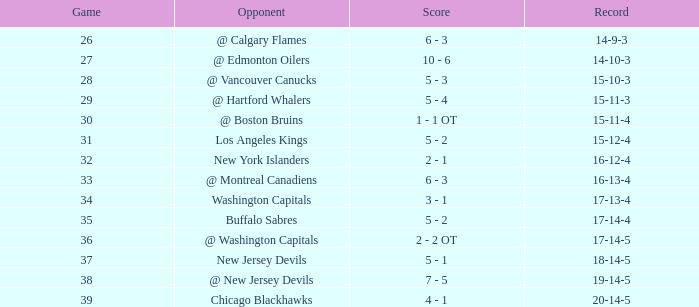Give me the full table as a dictionary. {'header': ['Game', 'Opponent', 'Score', 'Record'], 'rows': [['26', '@ Calgary Flames', '6 - 3', '14-9-3'], ['27', '@ Edmonton Oilers', '10 - 6', '14-10-3'], ['28', '@ Vancouver Canucks', '5 - 3', '15-10-3'], ['29', '@ Hartford Whalers', '5 - 4', '15-11-3'], ['30', '@ Boston Bruins', '1 - 1 OT', '15-11-4'], ['31', 'Los Angeles Kings', '5 - 2', '15-12-4'], ['32', 'New York Islanders', '2 - 1', '16-12-4'], ['33', '@ Montreal Canadiens', '6 - 3', '16-13-4'], ['34', 'Washington Capitals', '3 - 1', '17-13-4'], ['35', 'Buffalo Sabres', '5 - 2', '17-14-4'], ['36', '@ Washington Capitals', '2 - 2 OT', '17-14-5'], ['37', 'New Jersey Devils', '5 - 1', '18-14-5'], ['38', '@ New Jersey Devils', '7 - 5', '19-14-5'], ['39', 'Chicago Blackhawks', '4 - 1', '20-14-5']]} Game smaller than 34, and a December smaller than 14, and a Score of 10 - 6 has what opponent? @ Edmonton Oilers. 